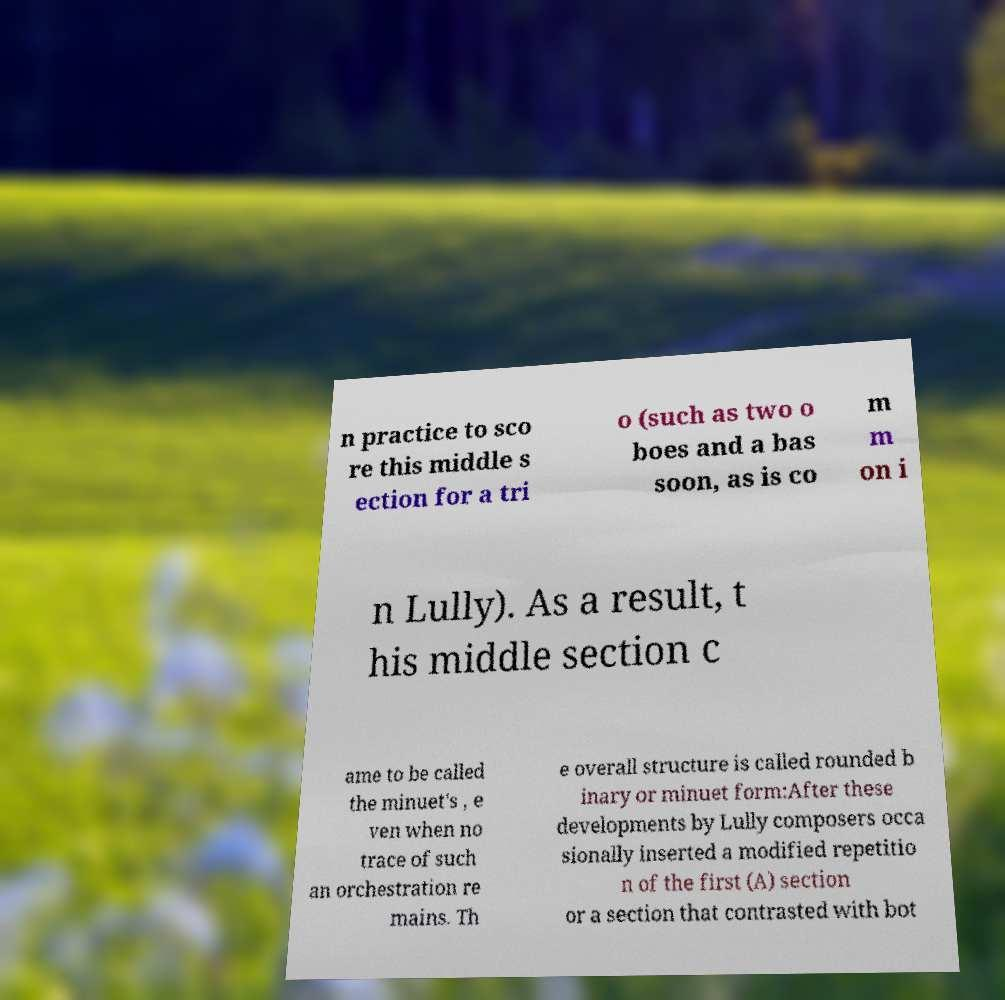For documentation purposes, I need the text within this image transcribed. Could you provide that? n practice to sco re this middle s ection for a tri o (such as two o boes and a bas soon, as is co m m on i n Lully). As a result, t his middle section c ame to be called the minuet's , e ven when no trace of such an orchestration re mains. Th e overall structure is called rounded b inary or minuet form:After these developments by Lully composers occa sionally inserted a modified repetitio n of the first (A) section or a section that contrasted with bot 